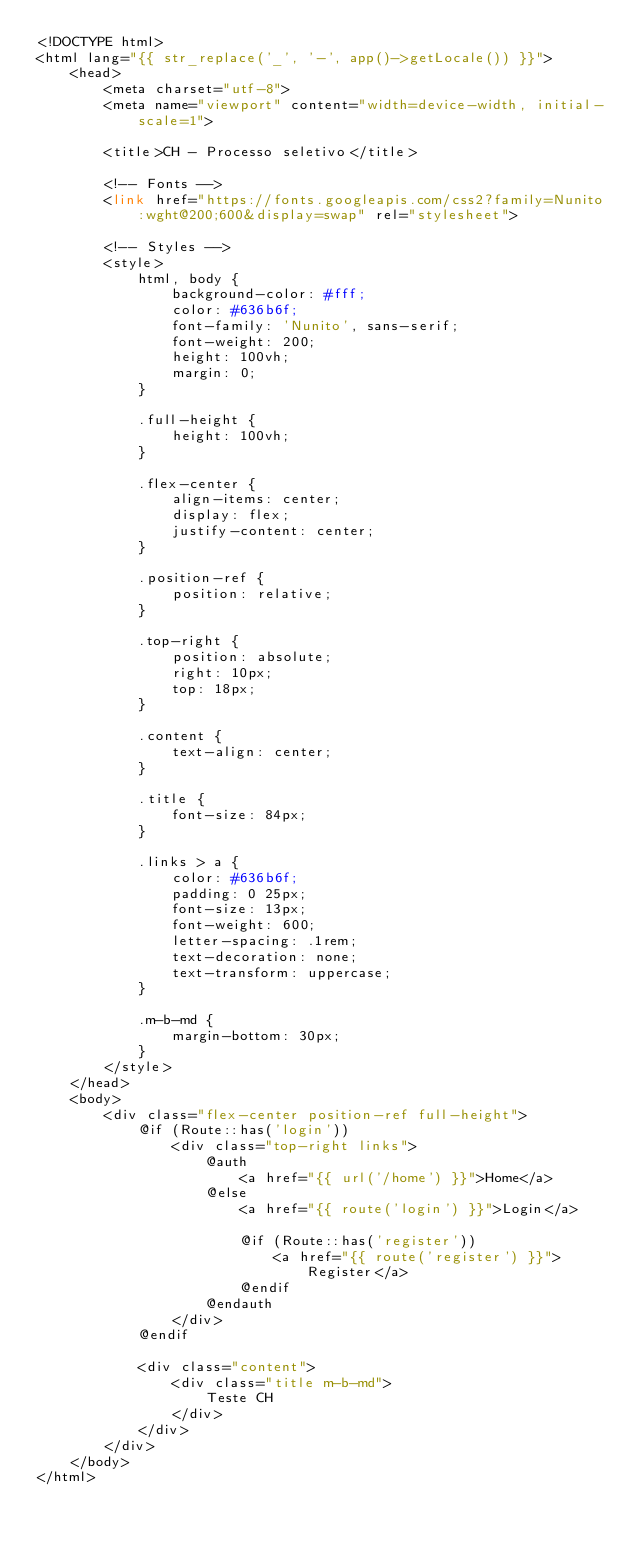Convert code to text. <code><loc_0><loc_0><loc_500><loc_500><_PHP_><!DOCTYPE html>
<html lang="{{ str_replace('_', '-', app()->getLocale()) }}">
    <head>
        <meta charset="utf-8">
        <meta name="viewport" content="width=device-width, initial-scale=1">

        <title>CH - Processo seletivo</title>

        <!-- Fonts -->
        <link href="https://fonts.googleapis.com/css2?family=Nunito:wght@200;600&display=swap" rel="stylesheet">

        <!-- Styles -->
        <style>
            html, body {
                background-color: #fff;
                color: #636b6f;
                font-family: 'Nunito', sans-serif;
                font-weight: 200;
                height: 100vh;
                margin: 0;
            }

            .full-height {
                height: 100vh;
            }

            .flex-center {
                align-items: center;
                display: flex;
                justify-content: center;
            }

            .position-ref {
                position: relative;
            }

            .top-right {
                position: absolute;
                right: 10px;
                top: 18px;
            }

            .content {
                text-align: center;
            }

            .title {
                font-size: 84px;
            }

            .links > a {
                color: #636b6f;
                padding: 0 25px;
                font-size: 13px;
                font-weight: 600;
                letter-spacing: .1rem;
                text-decoration: none;
                text-transform: uppercase;
            }

            .m-b-md {
                margin-bottom: 30px;
            }
        </style>
    </head>
    <body>
        <div class="flex-center position-ref full-height">
            @if (Route::has('login'))
                <div class="top-right links">
                    @auth
                        <a href="{{ url('/home') }}">Home</a>
                    @else
                        <a href="{{ route('login') }}">Login</a>

                        @if (Route::has('register'))
                            <a href="{{ route('register') }}">Register</a>
                        @endif
                    @endauth
                </div>
            @endif

            <div class="content">
                <div class="title m-b-md">
                    Teste CH
                </div>
            </div>
        </div>
    </body>
</html>
</code> 